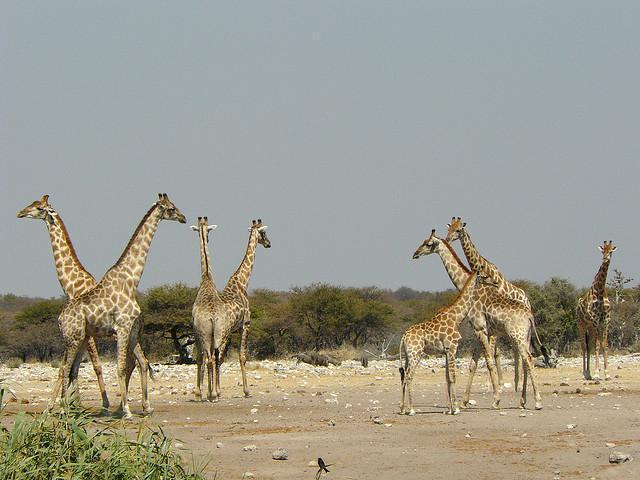How many giraffes are in the wild?
Give a very brief answer. 8. How many giraffes are there?
Give a very brief answer. 7. 